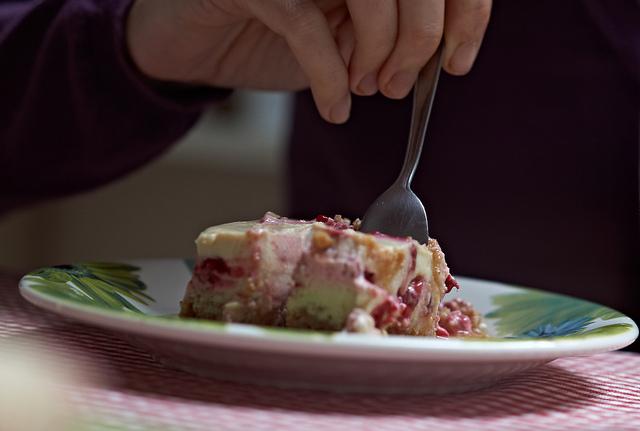What hand is this person using?
Be succinct. Right. What flavor is the frosting?
Be succinct. Strawberry. What are these people cutting?
Give a very brief answer. Cake. At what point in dinner might this be served?
Keep it brief. Dessert. What are they using to eat the food?
Quick response, please. Fork. What is the plate made of?
Answer briefly. Ceramic. What flavor ice cream is in the bowl?
Short answer required. Strawberry. 